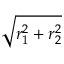Convert formula to latex. <formula><loc_0><loc_0><loc_500><loc_500>\sqrt { r _ { 1 } ^ { 2 } + r _ { 2 } ^ { 2 } }</formula> 